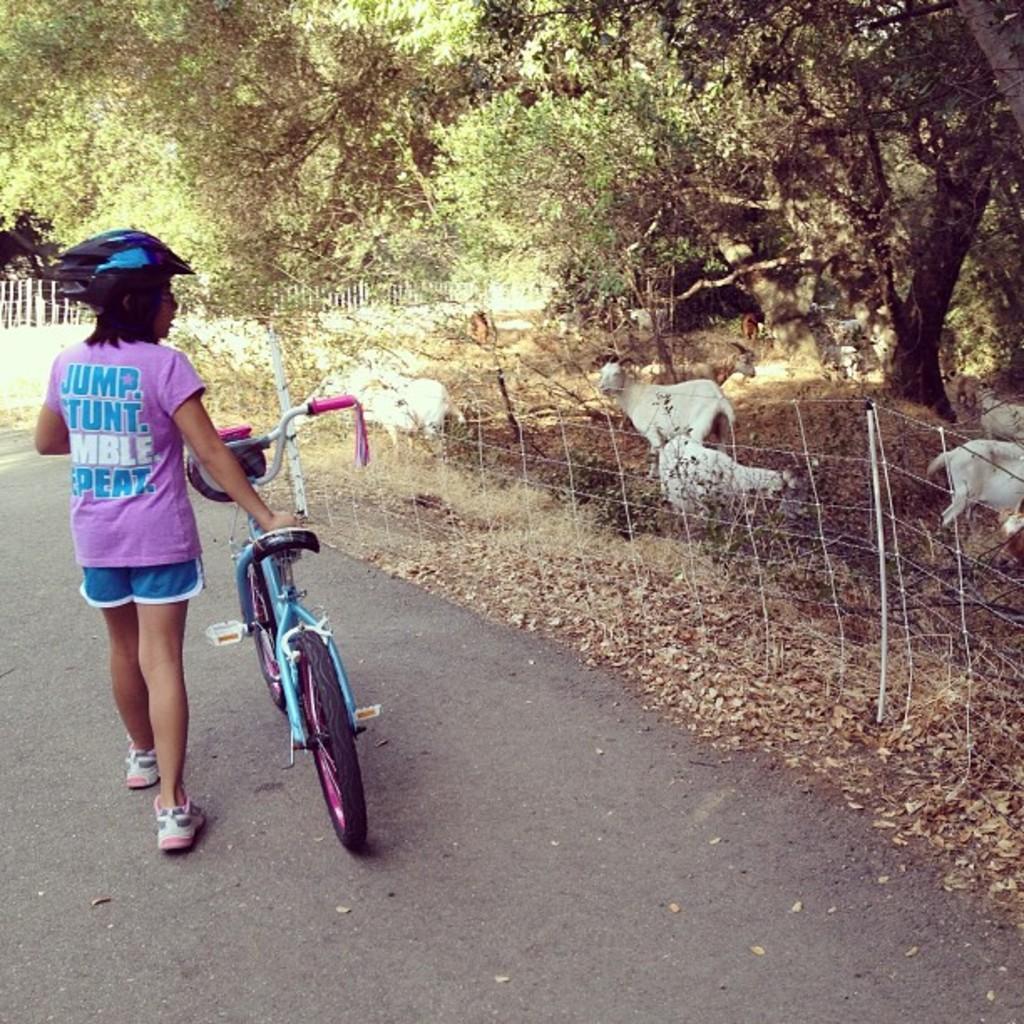Can you describe this image briefly? In this image we can see a girl wearing a helmet and holding a cycle. To the right side of the image there are trees, animals and fencing. 